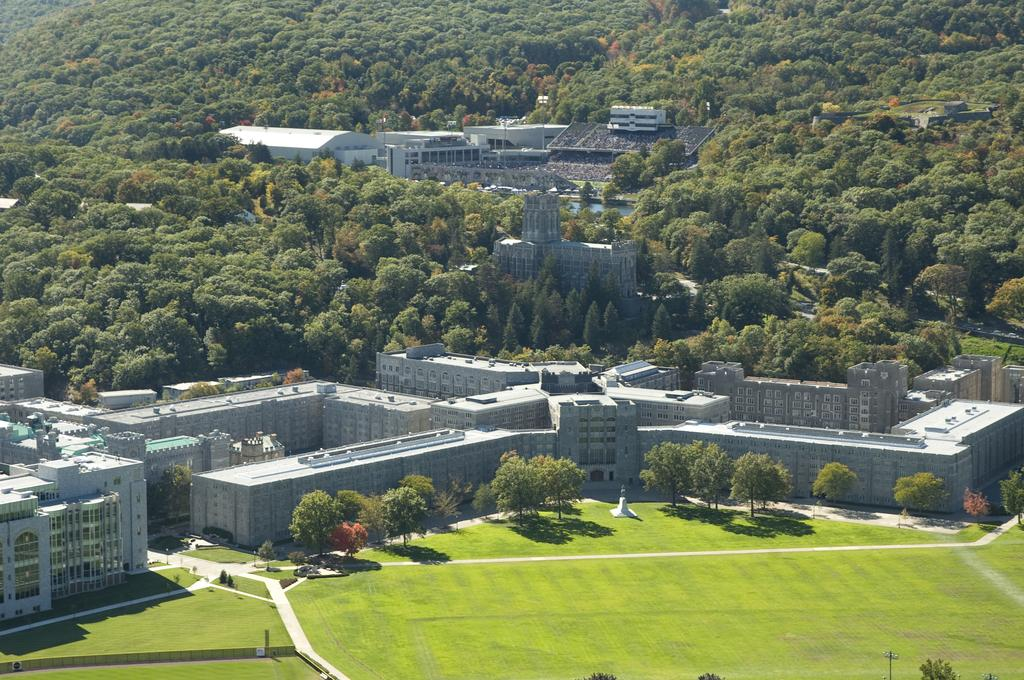What type of terrain is visible in the image? There is a grass lawn in the image. What other natural elements can be seen near the grass lawn? There are trees near the grass lawn. Are there any man-made structures visible in the image? Yes, there are buildings near the grass lawn and in the background of the image. What other natural elements can be seen in the background of the image? There are trees in the background of the image. How many friends is the passenger waving to in the image? There are no friends or passengers present in the image; it features a grass lawn, trees, and buildings. 